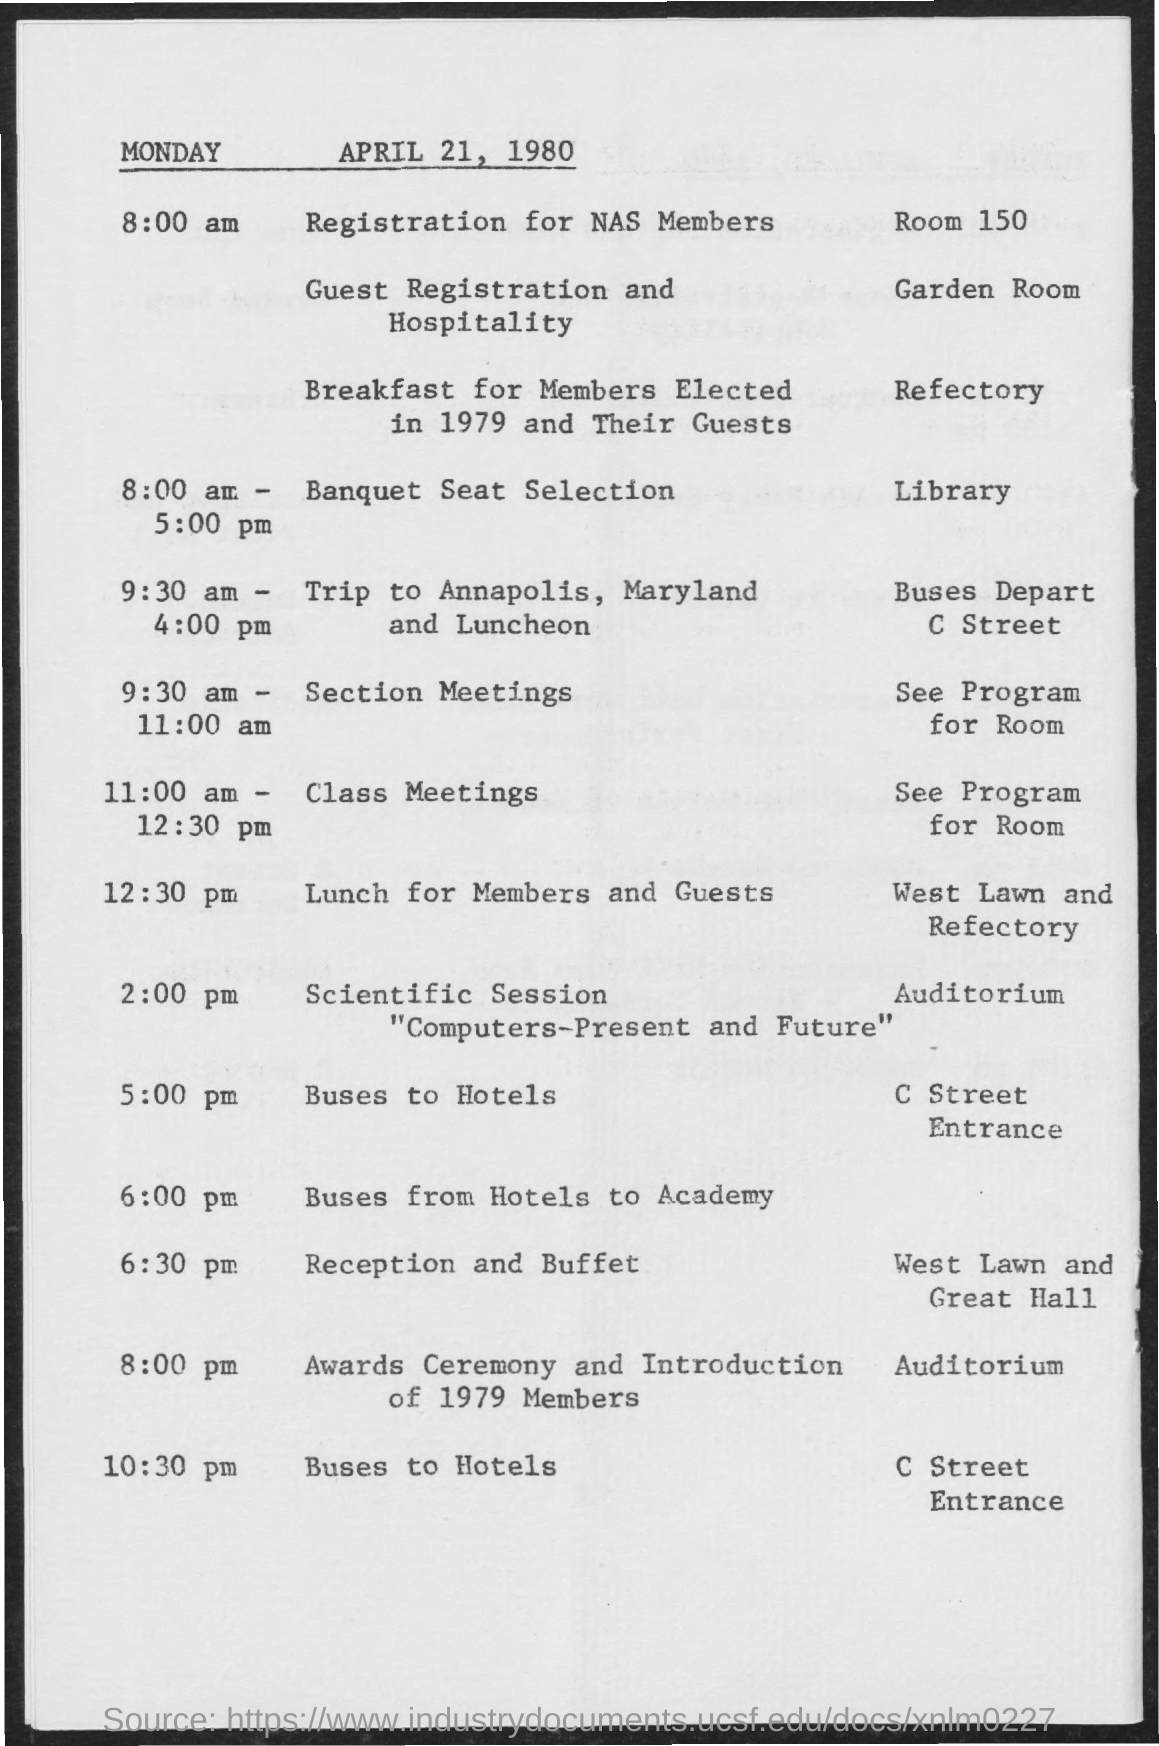What is the date mentioned in the given page ?
Offer a very short reply. MONDAY APRIL 21, 1980. What is the room no given for registration for nas members ?
Offer a terse response. 150. What is the room given for guest registration and hospitality ?
Provide a short and direct response. Garden Room. What is the timings given for trip to  annapolis,maryland and luncheon ?
Your answer should be compact. 9:30 am - 4:00 pm. At what time buses start from hotels to academy ?
Keep it short and to the point. 6:00 pm. At what place the awards ceremony and introduction of 1979 members took place ?
Provide a succinct answer. Auditorium. At what time reception and buffet were planned as per the given time table ?
Provide a short and direct response. 6:30 pm. 